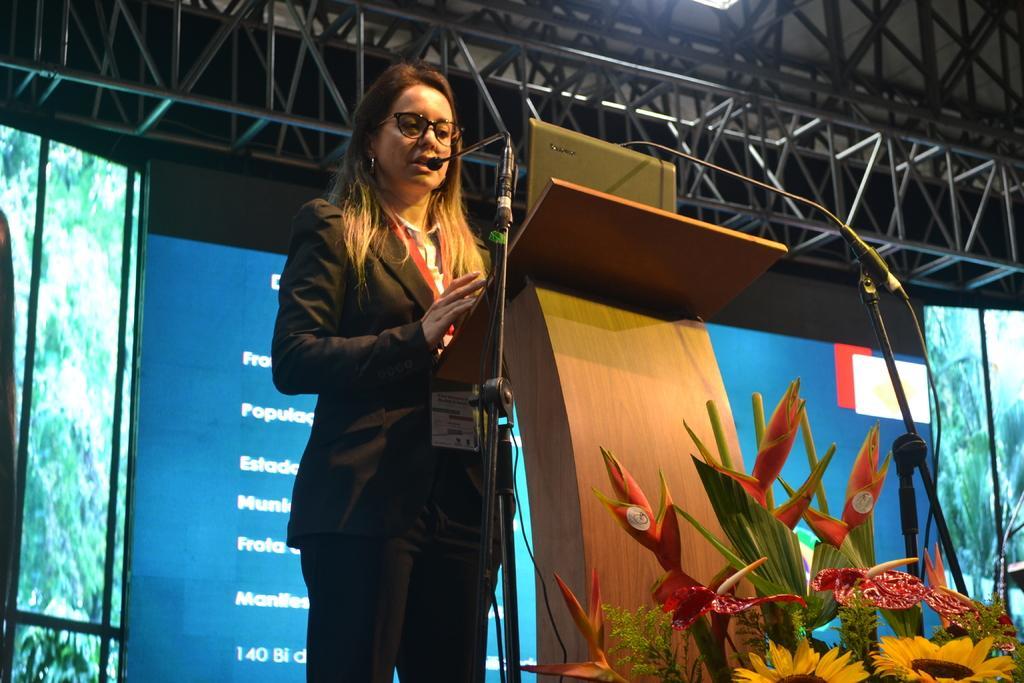Could you give a brief overview of what you see in this image? In this image we can see a woman wearing the glasses and standing in front of the podium and also the mics with stands. We can also see the laptop. In the background we can see the blue color banner with text. We can also see the screens and plants. At the top there is ceiling with the rods. We can also see the light. 